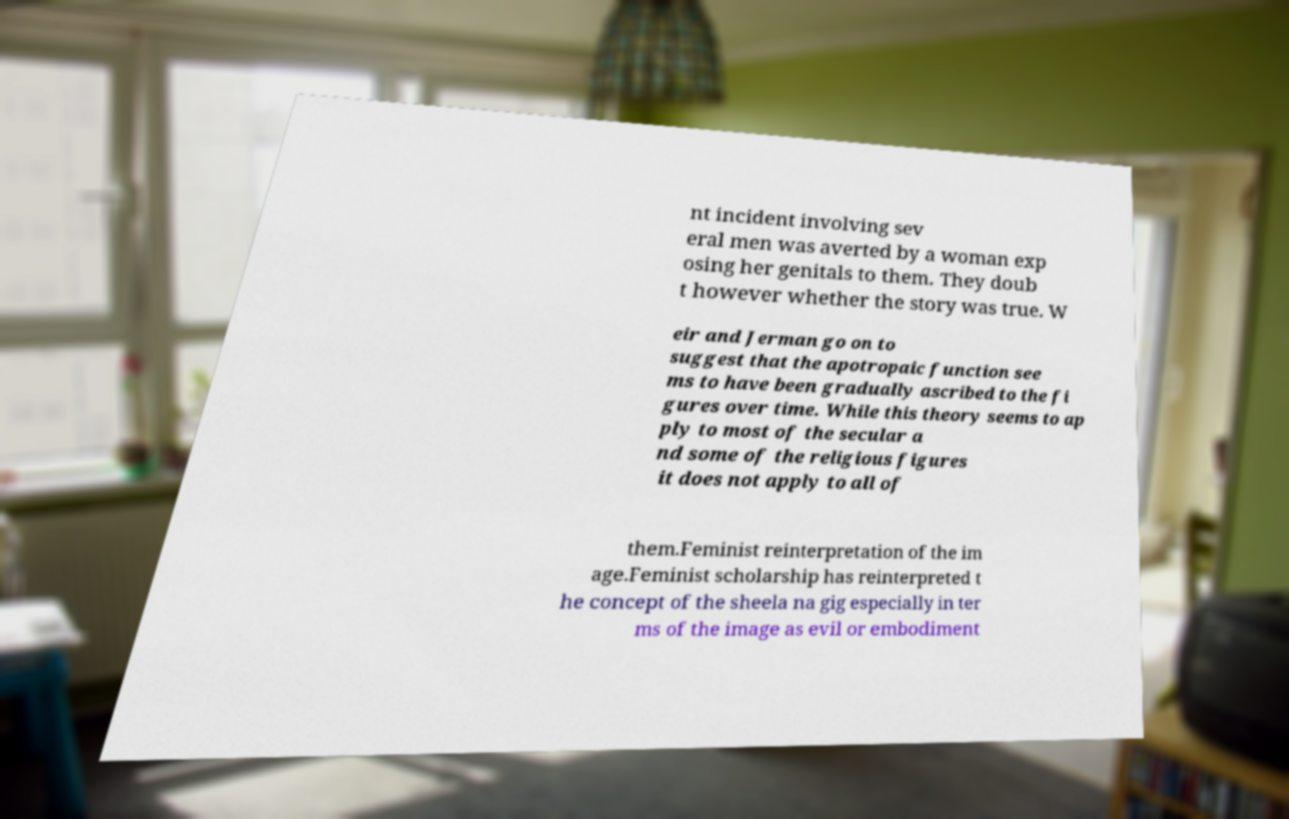Could you extract and type out the text from this image? nt incident involving sev eral men was averted by a woman exp osing her genitals to them. They doub t however whether the story was true. W eir and Jerman go on to suggest that the apotropaic function see ms to have been gradually ascribed to the fi gures over time. While this theory seems to ap ply to most of the secular a nd some of the religious figures it does not apply to all of them.Feminist reinterpretation of the im age.Feminist scholarship has reinterpreted t he concept of the sheela na gig especially in ter ms of the image as evil or embodiment 